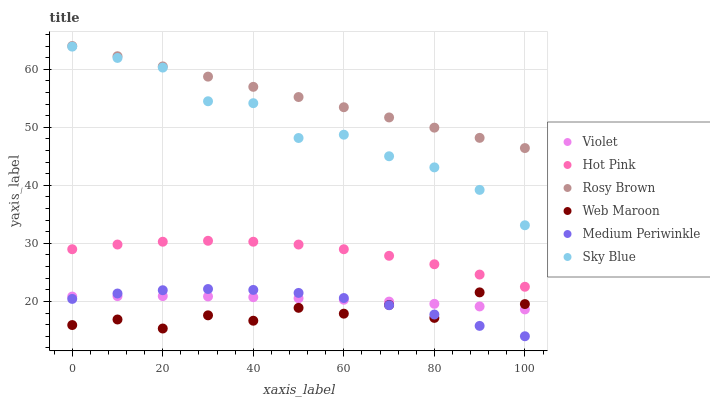Does Web Maroon have the minimum area under the curve?
Answer yes or no. Yes. Does Rosy Brown have the maximum area under the curve?
Answer yes or no. Yes. Does Rosy Brown have the minimum area under the curve?
Answer yes or no. No. Does Web Maroon have the maximum area under the curve?
Answer yes or no. No. Is Rosy Brown the smoothest?
Answer yes or no. Yes. Is Web Maroon the roughest?
Answer yes or no. Yes. Is Web Maroon the smoothest?
Answer yes or no. No. Is Rosy Brown the roughest?
Answer yes or no. No. Does Medium Periwinkle have the lowest value?
Answer yes or no. Yes. Does Web Maroon have the lowest value?
Answer yes or no. No. Does Rosy Brown have the highest value?
Answer yes or no. Yes. Does Web Maroon have the highest value?
Answer yes or no. No. Is Web Maroon less than Sky Blue?
Answer yes or no. Yes. Is Rosy Brown greater than Hot Pink?
Answer yes or no. Yes. Does Web Maroon intersect Medium Periwinkle?
Answer yes or no. Yes. Is Web Maroon less than Medium Periwinkle?
Answer yes or no. No. Is Web Maroon greater than Medium Periwinkle?
Answer yes or no. No. Does Web Maroon intersect Sky Blue?
Answer yes or no. No. 